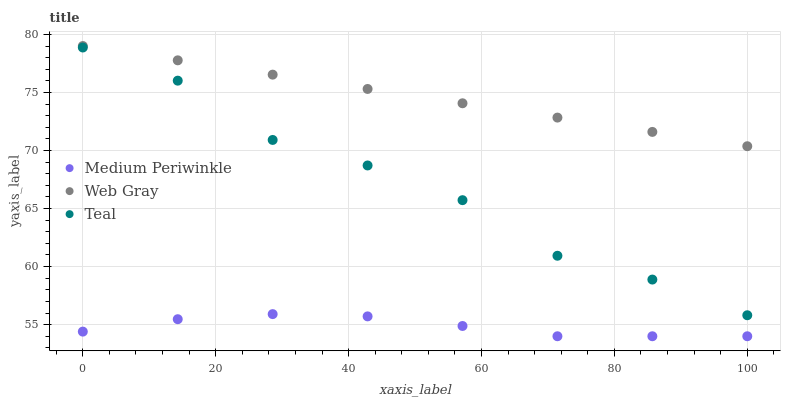Does Medium Periwinkle have the minimum area under the curve?
Answer yes or no. Yes. Does Web Gray have the maximum area under the curve?
Answer yes or no. Yes. Does Teal have the minimum area under the curve?
Answer yes or no. No. Does Teal have the maximum area under the curve?
Answer yes or no. No. Is Web Gray the smoothest?
Answer yes or no. Yes. Is Teal the roughest?
Answer yes or no. Yes. Is Medium Periwinkle the smoothest?
Answer yes or no. No. Is Medium Periwinkle the roughest?
Answer yes or no. No. Does Medium Periwinkle have the lowest value?
Answer yes or no. Yes. Does Teal have the lowest value?
Answer yes or no. No. Does Web Gray have the highest value?
Answer yes or no. Yes. Does Teal have the highest value?
Answer yes or no. No. Is Medium Periwinkle less than Web Gray?
Answer yes or no. Yes. Is Web Gray greater than Medium Periwinkle?
Answer yes or no. Yes. Does Medium Periwinkle intersect Web Gray?
Answer yes or no. No. 